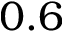<formula> <loc_0><loc_0><loc_500><loc_500>0 . 6</formula> 